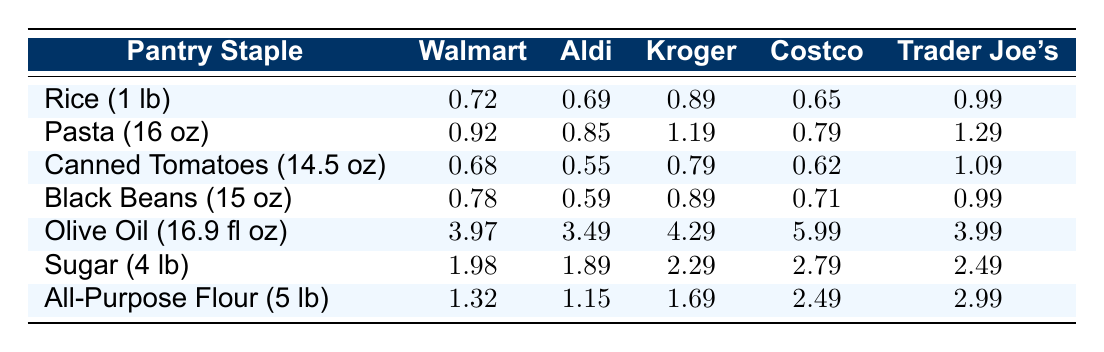What is the price of pasta at Aldi? The price listed for pasta (16 oz) at Aldi is 0.85, which can be found in the second row corresponding to Aldi's column.
Answer: 0.85 Which grocery chain has the cheapest price for rice? Looking at the prices for rice (1 lb), Costco has the lowest price of 0.65. This is found in the row for rice and compared across all chains.
Answer: Costco What is the difference in price for canned tomatoes between Aldi and Trader Joe's? The price for canned tomatoes (14.5 oz) at Aldi is 0.55 and at Trader Joe's it is 1.09. The difference is calculated by subtracting Aldi's price from Trader Joe's price: 1.09 - 0.55 = 0.54.
Answer: 0.54 Is the price of olive oil at Walmart higher than at Aldi? The price for olive oil (16.9 fl oz) at Walmart is 3.97, and Aldi's price is 3.49. Since 3.97 is greater than 3.49, the statement is true.
Answer: Yes What is the average price of black beans across all grocery chains? To find the average price of black beans (15 oz), we sum the prices: 0.78 (Walmart) + 0.59 (Aldi) + 0.89 (Kroger) + 0.71 (Costco) + 0.99 (Trader Joe's) = 3.96. Then we divide by the number of stores (5): 3.96 / 5 = 0.792.
Answer: 0.792 Which pantry staple has the highest price at Costco? Reviewing the prices at Costco, olive oil (16.9 fl oz) is the highest at 5.99, as seen in the respective row for this item.
Answer: Olive oil How much does sugar (4 lb) cost at Kroger compared to Walmart? At Kroger, sugar (4 lb) costs 2.29, while at Walmart, it costs 1.98. Comparing these prices shows that the difference is 2.29 - 1.98 = 0.31, meaning Kroger's price is higher by that amount.
Answer: Kroger is higher by 0.31 Are Aldi's prices consistently lower than Walmart's for the items shown? By comparing each corresponding price row for Walmart and Aldi, it is clear that Aldi is cheaper for rice, pasta, canned tomatoes, and black beans, but not for olive oil or sugar. Therefore, the statement is false.
Answer: No 